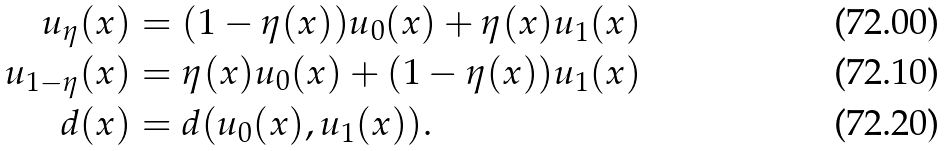<formula> <loc_0><loc_0><loc_500><loc_500>u _ { \eta } ( x ) & = ( 1 - \eta ( x ) ) u _ { 0 } ( x ) + \eta ( x ) u _ { 1 } ( x ) \\ u _ { 1 - \eta } ( x ) & = \eta ( x ) u _ { 0 } ( x ) + ( 1 - \eta ( x ) ) u _ { 1 } ( x ) \\ d ( x ) & = d ( u _ { 0 } ( x ) , u _ { 1 } ( x ) ) .</formula> 